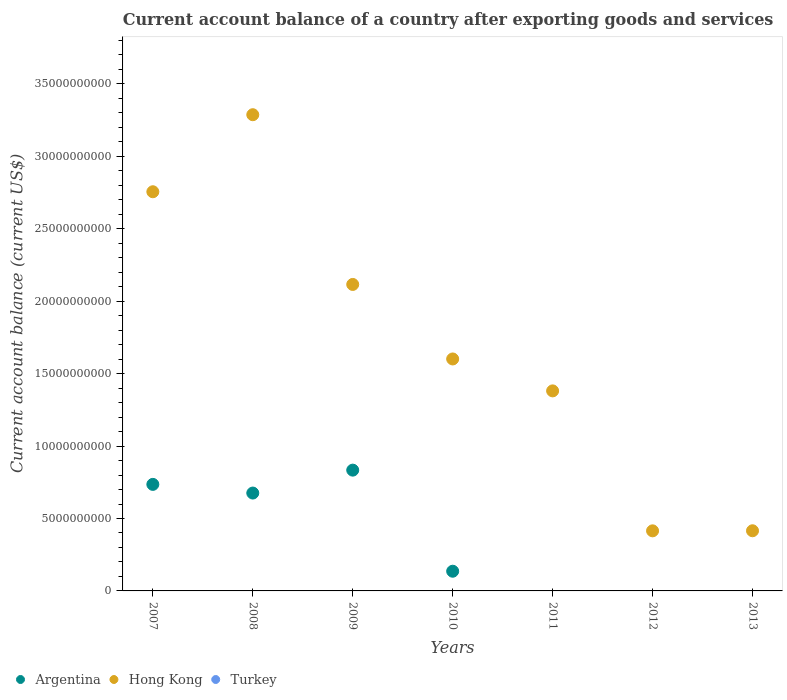How many different coloured dotlines are there?
Provide a short and direct response. 2. Is the number of dotlines equal to the number of legend labels?
Provide a short and direct response. No. What is the account balance in Argentina in 2008?
Your answer should be compact. 6.76e+09. Across all years, what is the maximum account balance in Hong Kong?
Your answer should be very brief. 3.29e+1. Across all years, what is the minimum account balance in Hong Kong?
Your response must be concise. 4.15e+09. In which year was the account balance in Argentina maximum?
Offer a terse response. 2009. What is the total account balance in Turkey in the graph?
Keep it short and to the point. 0. What is the difference between the account balance in Hong Kong in 2007 and that in 2012?
Keep it short and to the point. 2.34e+1. What is the difference between the account balance in Hong Kong in 2011 and the account balance in Turkey in 2007?
Your answer should be very brief. 1.38e+1. What is the average account balance in Turkey per year?
Make the answer very short. 0. In the year 2009, what is the difference between the account balance in Hong Kong and account balance in Argentina?
Make the answer very short. 1.28e+1. What is the ratio of the account balance in Hong Kong in 2008 to that in 2010?
Your answer should be very brief. 2.05. What is the difference between the highest and the second highest account balance in Hong Kong?
Make the answer very short. 5.32e+09. What is the difference between the highest and the lowest account balance in Argentina?
Provide a succinct answer. 8.34e+09. How many years are there in the graph?
Provide a succinct answer. 7. What is the difference between two consecutive major ticks on the Y-axis?
Provide a short and direct response. 5.00e+09. Are the values on the major ticks of Y-axis written in scientific E-notation?
Provide a short and direct response. No. Does the graph contain any zero values?
Make the answer very short. Yes. Does the graph contain grids?
Your answer should be compact. No. Where does the legend appear in the graph?
Provide a short and direct response. Bottom left. How many legend labels are there?
Keep it short and to the point. 3. What is the title of the graph?
Offer a very short reply. Current account balance of a country after exporting goods and services. Does "Denmark" appear as one of the legend labels in the graph?
Provide a short and direct response. No. What is the label or title of the Y-axis?
Ensure brevity in your answer.  Current account balance (current US$). What is the Current account balance (current US$) in Argentina in 2007?
Offer a terse response. 7.35e+09. What is the Current account balance (current US$) in Hong Kong in 2007?
Ensure brevity in your answer.  2.76e+1. What is the Current account balance (current US$) of Turkey in 2007?
Offer a terse response. 0. What is the Current account balance (current US$) in Argentina in 2008?
Offer a terse response. 6.76e+09. What is the Current account balance (current US$) of Hong Kong in 2008?
Your answer should be very brief. 3.29e+1. What is the Current account balance (current US$) of Argentina in 2009?
Give a very brief answer. 8.34e+09. What is the Current account balance (current US$) in Hong Kong in 2009?
Provide a succinct answer. 2.12e+1. What is the Current account balance (current US$) in Argentina in 2010?
Offer a terse response. 1.36e+09. What is the Current account balance (current US$) of Hong Kong in 2010?
Make the answer very short. 1.60e+1. What is the Current account balance (current US$) in Argentina in 2011?
Give a very brief answer. 0. What is the Current account balance (current US$) in Hong Kong in 2011?
Ensure brevity in your answer.  1.38e+1. What is the Current account balance (current US$) in Turkey in 2011?
Your answer should be compact. 0. What is the Current account balance (current US$) in Hong Kong in 2012?
Keep it short and to the point. 4.15e+09. What is the Current account balance (current US$) of Turkey in 2012?
Provide a short and direct response. 0. What is the Current account balance (current US$) in Argentina in 2013?
Make the answer very short. 0. What is the Current account balance (current US$) in Hong Kong in 2013?
Keep it short and to the point. 4.15e+09. Across all years, what is the maximum Current account balance (current US$) in Argentina?
Make the answer very short. 8.34e+09. Across all years, what is the maximum Current account balance (current US$) of Hong Kong?
Ensure brevity in your answer.  3.29e+1. Across all years, what is the minimum Current account balance (current US$) in Argentina?
Provide a short and direct response. 0. Across all years, what is the minimum Current account balance (current US$) in Hong Kong?
Offer a terse response. 4.15e+09. What is the total Current account balance (current US$) of Argentina in the graph?
Provide a succinct answer. 2.38e+1. What is the total Current account balance (current US$) of Hong Kong in the graph?
Provide a short and direct response. 1.20e+11. What is the difference between the Current account balance (current US$) of Argentina in 2007 and that in 2008?
Make the answer very short. 5.98e+08. What is the difference between the Current account balance (current US$) of Hong Kong in 2007 and that in 2008?
Make the answer very short. -5.32e+09. What is the difference between the Current account balance (current US$) of Argentina in 2007 and that in 2009?
Offer a very short reply. -9.83e+08. What is the difference between the Current account balance (current US$) of Hong Kong in 2007 and that in 2009?
Ensure brevity in your answer.  6.40e+09. What is the difference between the Current account balance (current US$) in Argentina in 2007 and that in 2010?
Your answer should be very brief. 5.99e+09. What is the difference between the Current account balance (current US$) in Hong Kong in 2007 and that in 2010?
Give a very brief answer. 1.15e+1. What is the difference between the Current account balance (current US$) of Hong Kong in 2007 and that in 2011?
Offer a terse response. 1.37e+1. What is the difference between the Current account balance (current US$) in Hong Kong in 2007 and that in 2012?
Offer a terse response. 2.34e+1. What is the difference between the Current account balance (current US$) in Hong Kong in 2007 and that in 2013?
Provide a short and direct response. 2.34e+1. What is the difference between the Current account balance (current US$) of Argentina in 2008 and that in 2009?
Your answer should be very brief. -1.58e+09. What is the difference between the Current account balance (current US$) in Hong Kong in 2008 and that in 2009?
Your answer should be very brief. 1.17e+1. What is the difference between the Current account balance (current US$) in Argentina in 2008 and that in 2010?
Ensure brevity in your answer.  5.40e+09. What is the difference between the Current account balance (current US$) in Hong Kong in 2008 and that in 2010?
Provide a succinct answer. 1.69e+1. What is the difference between the Current account balance (current US$) of Hong Kong in 2008 and that in 2011?
Ensure brevity in your answer.  1.91e+1. What is the difference between the Current account balance (current US$) in Hong Kong in 2008 and that in 2012?
Offer a very short reply. 2.87e+1. What is the difference between the Current account balance (current US$) of Hong Kong in 2008 and that in 2013?
Offer a very short reply. 2.87e+1. What is the difference between the Current account balance (current US$) in Argentina in 2009 and that in 2010?
Provide a short and direct response. 6.98e+09. What is the difference between the Current account balance (current US$) of Hong Kong in 2009 and that in 2010?
Provide a short and direct response. 5.14e+09. What is the difference between the Current account balance (current US$) of Hong Kong in 2009 and that in 2011?
Provide a short and direct response. 7.35e+09. What is the difference between the Current account balance (current US$) of Hong Kong in 2009 and that in 2012?
Offer a terse response. 1.70e+1. What is the difference between the Current account balance (current US$) in Hong Kong in 2009 and that in 2013?
Offer a very short reply. 1.70e+1. What is the difference between the Current account balance (current US$) in Hong Kong in 2010 and that in 2011?
Your response must be concise. 2.20e+09. What is the difference between the Current account balance (current US$) of Hong Kong in 2010 and that in 2012?
Make the answer very short. 1.19e+1. What is the difference between the Current account balance (current US$) in Hong Kong in 2010 and that in 2013?
Provide a succinct answer. 1.19e+1. What is the difference between the Current account balance (current US$) of Hong Kong in 2011 and that in 2012?
Your answer should be compact. 9.66e+09. What is the difference between the Current account balance (current US$) in Hong Kong in 2011 and that in 2013?
Make the answer very short. 9.66e+09. What is the difference between the Current account balance (current US$) of Hong Kong in 2012 and that in 2013?
Your response must be concise. -5.30e+06. What is the difference between the Current account balance (current US$) of Argentina in 2007 and the Current account balance (current US$) of Hong Kong in 2008?
Keep it short and to the point. -2.55e+1. What is the difference between the Current account balance (current US$) of Argentina in 2007 and the Current account balance (current US$) of Hong Kong in 2009?
Make the answer very short. -1.38e+1. What is the difference between the Current account balance (current US$) in Argentina in 2007 and the Current account balance (current US$) in Hong Kong in 2010?
Provide a succinct answer. -8.66e+09. What is the difference between the Current account balance (current US$) in Argentina in 2007 and the Current account balance (current US$) in Hong Kong in 2011?
Make the answer very short. -6.45e+09. What is the difference between the Current account balance (current US$) of Argentina in 2007 and the Current account balance (current US$) of Hong Kong in 2012?
Your answer should be compact. 3.21e+09. What is the difference between the Current account balance (current US$) of Argentina in 2007 and the Current account balance (current US$) of Hong Kong in 2013?
Ensure brevity in your answer.  3.20e+09. What is the difference between the Current account balance (current US$) in Argentina in 2008 and the Current account balance (current US$) in Hong Kong in 2009?
Provide a short and direct response. -1.44e+1. What is the difference between the Current account balance (current US$) in Argentina in 2008 and the Current account balance (current US$) in Hong Kong in 2010?
Offer a very short reply. -9.26e+09. What is the difference between the Current account balance (current US$) of Argentina in 2008 and the Current account balance (current US$) of Hong Kong in 2011?
Give a very brief answer. -7.05e+09. What is the difference between the Current account balance (current US$) in Argentina in 2008 and the Current account balance (current US$) in Hong Kong in 2012?
Make the answer very short. 2.61e+09. What is the difference between the Current account balance (current US$) of Argentina in 2008 and the Current account balance (current US$) of Hong Kong in 2013?
Offer a terse response. 2.60e+09. What is the difference between the Current account balance (current US$) of Argentina in 2009 and the Current account balance (current US$) of Hong Kong in 2010?
Provide a succinct answer. -7.67e+09. What is the difference between the Current account balance (current US$) in Argentina in 2009 and the Current account balance (current US$) in Hong Kong in 2011?
Offer a very short reply. -5.47e+09. What is the difference between the Current account balance (current US$) in Argentina in 2009 and the Current account balance (current US$) in Hong Kong in 2012?
Offer a terse response. 4.19e+09. What is the difference between the Current account balance (current US$) in Argentina in 2009 and the Current account balance (current US$) in Hong Kong in 2013?
Your answer should be very brief. 4.18e+09. What is the difference between the Current account balance (current US$) in Argentina in 2010 and the Current account balance (current US$) in Hong Kong in 2011?
Offer a very short reply. -1.24e+1. What is the difference between the Current account balance (current US$) of Argentina in 2010 and the Current account balance (current US$) of Hong Kong in 2012?
Your response must be concise. -2.79e+09. What is the difference between the Current account balance (current US$) in Argentina in 2010 and the Current account balance (current US$) in Hong Kong in 2013?
Provide a short and direct response. -2.79e+09. What is the average Current account balance (current US$) in Argentina per year?
Your answer should be compact. 3.40e+09. What is the average Current account balance (current US$) in Hong Kong per year?
Provide a short and direct response. 1.71e+1. In the year 2007, what is the difference between the Current account balance (current US$) in Argentina and Current account balance (current US$) in Hong Kong?
Your response must be concise. -2.02e+1. In the year 2008, what is the difference between the Current account balance (current US$) of Argentina and Current account balance (current US$) of Hong Kong?
Make the answer very short. -2.61e+1. In the year 2009, what is the difference between the Current account balance (current US$) in Argentina and Current account balance (current US$) in Hong Kong?
Make the answer very short. -1.28e+1. In the year 2010, what is the difference between the Current account balance (current US$) in Argentina and Current account balance (current US$) in Hong Kong?
Ensure brevity in your answer.  -1.47e+1. What is the ratio of the Current account balance (current US$) in Argentina in 2007 to that in 2008?
Your response must be concise. 1.09. What is the ratio of the Current account balance (current US$) of Hong Kong in 2007 to that in 2008?
Your answer should be very brief. 0.84. What is the ratio of the Current account balance (current US$) of Argentina in 2007 to that in 2009?
Your answer should be very brief. 0.88. What is the ratio of the Current account balance (current US$) in Hong Kong in 2007 to that in 2009?
Your answer should be compact. 1.3. What is the ratio of the Current account balance (current US$) of Argentina in 2007 to that in 2010?
Your answer should be very brief. 5.41. What is the ratio of the Current account balance (current US$) of Hong Kong in 2007 to that in 2010?
Offer a very short reply. 1.72. What is the ratio of the Current account balance (current US$) in Hong Kong in 2007 to that in 2011?
Your answer should be compact. 2. What is the ratio of the Current account balance (current US$) of Hong Kong in 2007 to that in 2012?
Keep it short and to the point. 6.64. What is the ratio of the Current account balance (current US$) in Hong Kong in 2007 to that in 2013?
Your answer should be compact. 6.64. What is the ratio of the Current account balance (current US$) of Argentina in 2008 to that in 2009?
Provide a succinct answer. 0.81. What is the ratio of the Current account balance (current US$) in Hong Kong in 2008 to that in 2009?
Give a very brief answer. 1.55. What is the ratio of the Current account balance (current US$) in Argentina in 2008 to that in 2010?
Offer a terse response. 4.97. What is the ratio of the Current account balance (current US$) in Hong Kong in 2008 to that in 2010?
Provide a succinct answer. 2.05. What is the ratio of the Current account balance (current US$) of Hong Kong in 2008 to that in 2011?
Ensure brevity in your answer.  2.38. What is the ratio of the Current account balance (current US$) in Hong Kong in 2008 to that in 2012?
Make the answer very short. 7.93. What is the ratio of the Current account balance (current US$) in Hong Kong in 2008 to that in 2013?
Make the answer very short. 7.92. What is the ratio of the Current account balance (current US$) of Argentina in 2009 to that in 2010?
Provide a short and direct response. 6.13. What is the ratio of the Current account balance (current US$) of Hong Kong in 2009 to that in 2010?
Your answer should be very brief. 1.32. What is the ratio of the Current account balance (current US$) in Hong Kong in 2009 to that in 2011?
Make the answer very short. 1.53. What is the ratio of the Current account balance (current US$) of Hong Kong in 2009 to that in 2012?
Ensure brevity in your answer.  5.1. What is the ratio of the Current account balance (current US$) of Hong Kong in 2009 to that in 2013?
Offer a terse response. 5.09. What is the ratio of the Current account balance (current US$) in Hong Kong in 2010 to that in 2011?
Give a very brief answer. 1.16. What is the ratio of the Current account balance (current US$) in Hong Kong in 2010 to that in 2012?
Give a very brief answer. 3.86. What is the ratio of the Current account balance (current US$) in Hong Kong in 2010 to that in 2013?
Keep it short and to the point. 3.86. What is the ratio of the Current account balance (current US$) in Hong Kong in 2011 to that in 2012?
Your answer should be very brief. 3.33. What is the ratio of the Current account balance (current US$) of Hong Kong in 2011 to that in 2013?
Keep it short and to the point. 3.33. What is the ratio of the Current account balance (current US$) in Hong Kong in 2012 to that in 2013?
Give a very brief answer. 1. What is the difference between the highest and the second highest Current account balance (current US$) in Argentina?
Your response must be concise. 9.83e+08. What is the difference between the highest and the second highest Current account balance (current US$) of Hong Kong?
Provide a short and direct response. 5.32e+09. What is the difference between the highest and the lowest Current account balance (current US$) in Argentina?
Provide a succinct answer. 8.34e+09. What is the difference between the highest and the lowest Current account balance (current US$) in Hong Kong?
Offer a very short reply. 2.87e+1. 